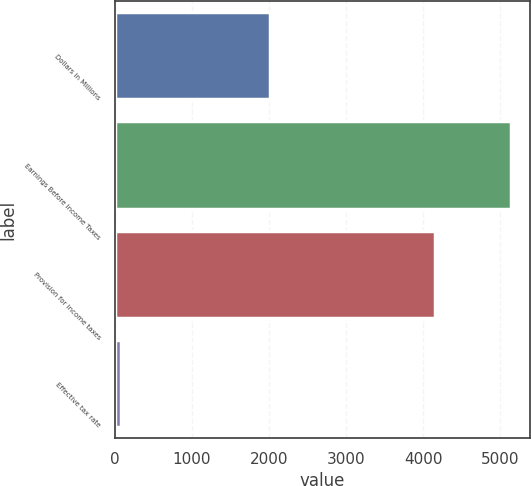<chart> <loc_0><loc_0><loc_500><loc_500><bar_chart><fcel>Dollars in Millions<fcel>Earnings Before Income Taxes<fcel>Provision for income taxes<fcel>Effective tax rate<nl><fcel>2017<fcel>5131<fcel>4156<fcel>81<nl></chart> 